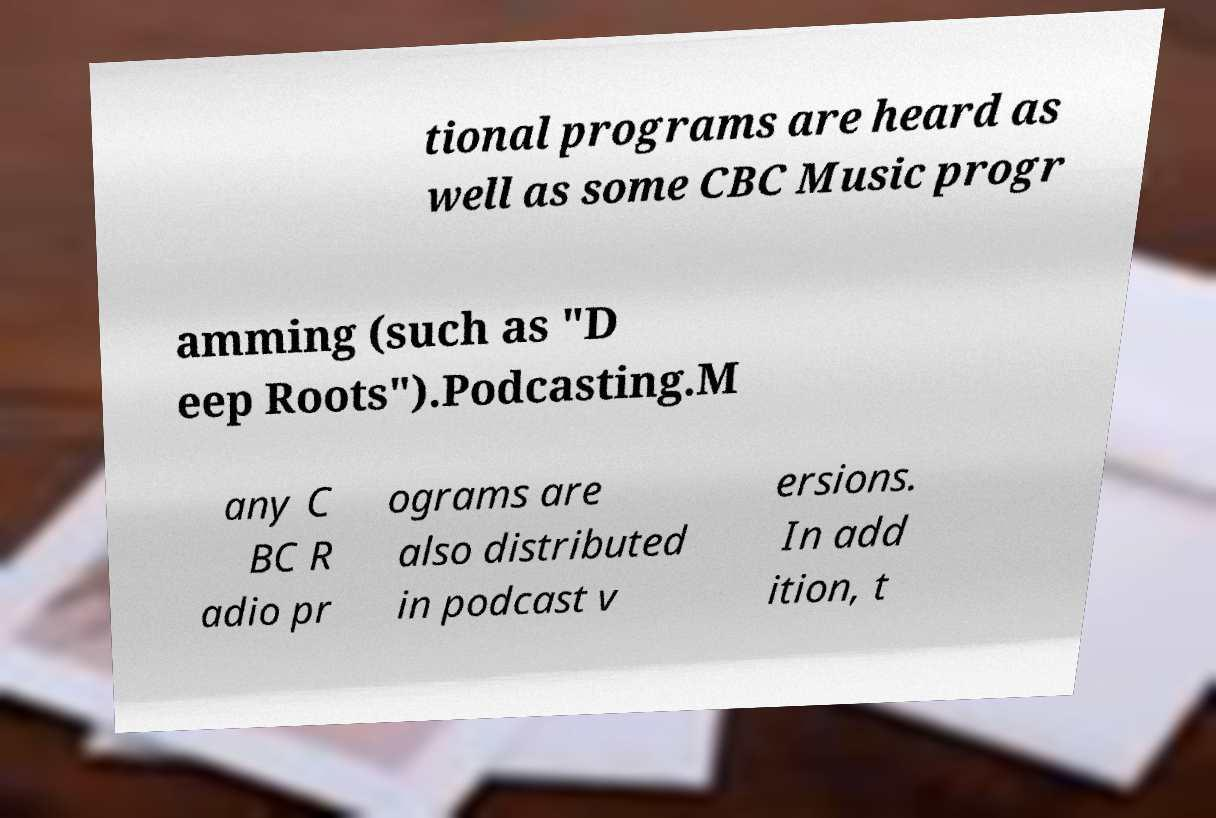Could you assist in decoding the text presented in this image and type it out clearly? tional programs are heard as well as some CBC Music progr amming (such as "D eep Roots").Podcasting.M any C BC R adio pr ograms are also distributed in podcast v ersions. In add ition, t 